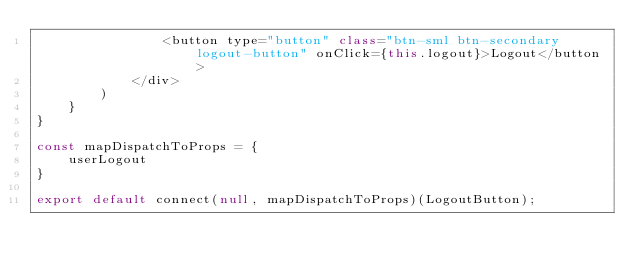<code> <loc_0><loc_0><loc_500><loc_500><_JavaScript_>                <button type="button" class="btn-sml btn-secondary logout-button" onClick={this.logout}>Logout</button>
            </div>
        )
    }
}

const mapDispatchToProps = {
    userLogout
}

export default connect(null, mapDispatchToProps)(LogoutButton);</code> 